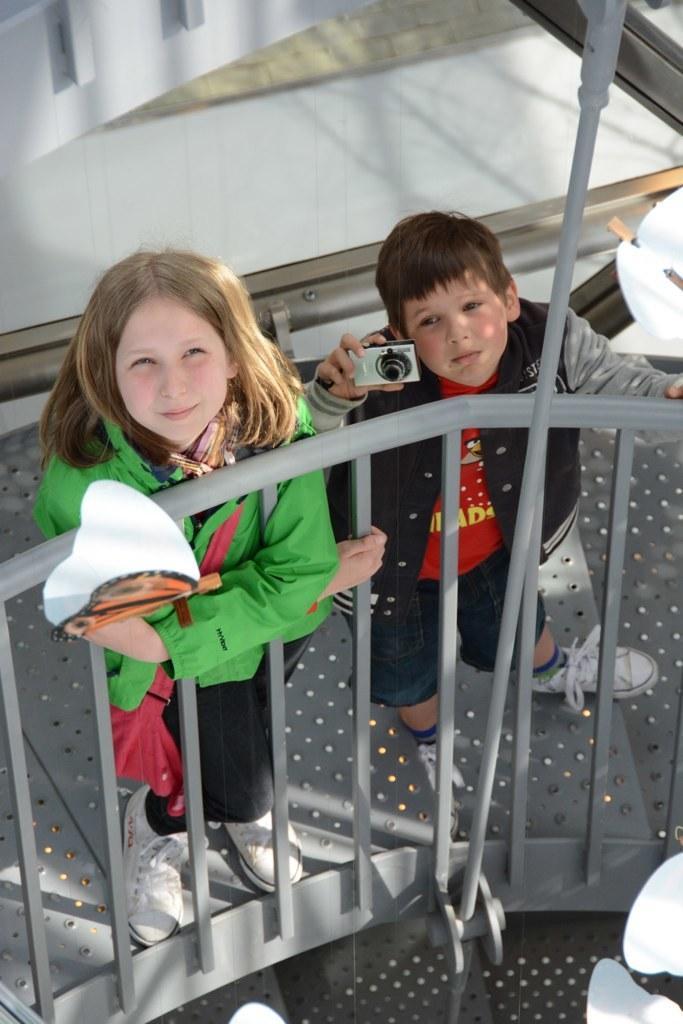How would you summarize this image in a sentence or two? In this image there are two kids standing on the metal platform with the rods. The girl is holding the object and a boy is holding the camera. In the background of the image there is a wall. 